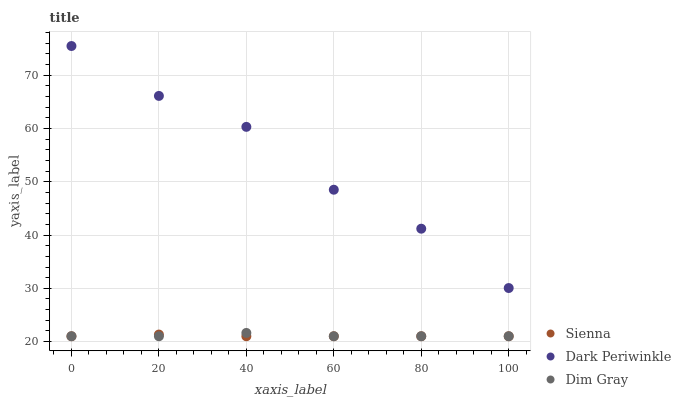Does Sienna have the minimum area under the curve?
Answer yes or no. Yes. Does Dark Periwinkle have the maximum area under the curve?
Answer yes or no. Yes. Does Dim Gray have the minimum area under the curve?
Answer yes or no. No. Does Dim Gray have the maximum area under the curve?
Answer yes or no. No. Is Sienna the smoothest?
Answer yes or no. Yes. Is Dark Periwinkle the roughest?
Answer yes or no. Yes. Is Dim Gray the smoothest?
Answer yes or no. No. Is Dim Gray the roughest?
Answer yes or no. No. Does Sienna have the lowest value?
Answer yes or no. Yes. Does Dark Periwinkle have the lowest value?
Answer yes or no. No. Does Dark Periwinkle have the highest value?
Answer yes or no. Yes. Does Dim Gray have the highest value?
Answer yes or no. No. Is Dim Gray less than Dark Periwinkle?
Answer yes or no. Yes. Is Dark Periwinkle greater than Sienna?
Answer yes or no. Yes. Does Sienna intersect Dim Gray?
Answer yes or no. Yes. Is Sienna less than Dim Gray?
Answer yes or no. No. Is Sienna greater than Dim Gray?
Answer yes or no. No. Does Dim Gray intersect Dark Periwinkle?
Answer yes or no. No. 